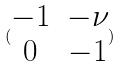<formula> <loc_0><loc_0><loc_500><loc_500>( \begin{matrix} - 1 & - \nu \\ 0 & - 1 \end{matrix} )</formula> 